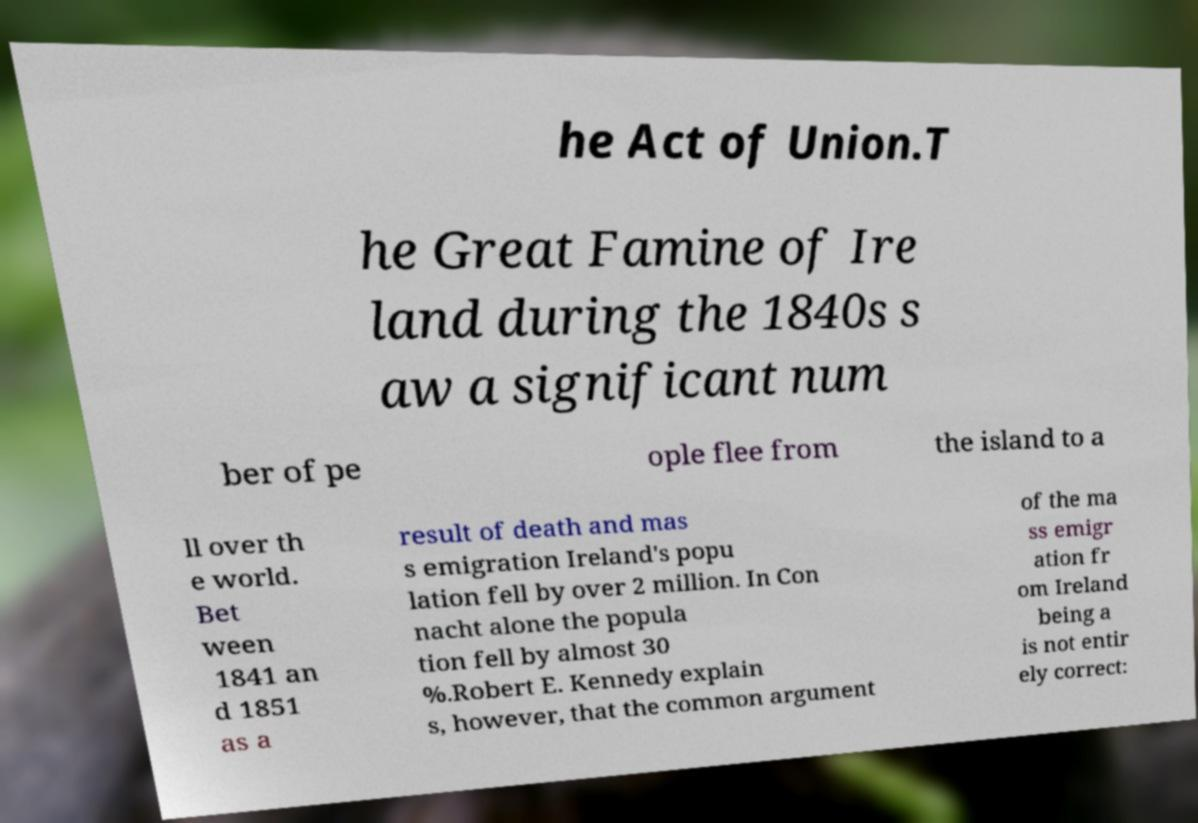Please read and relay the text visible in this image. What does it say? he Act of Union.T he Great Famine of Ire land during the 1840s s aw a significant num ber of pe ople flee from the island to a ll over th e world. Bet ween 1841 an d 1851 as a result of death and mas s emigration Ireland's popu lation fell by over 2 million. In Con nacht alone the popula tion fell by almost 30 %.Robert E. Kennedy explain s, however, that the common argument of the ma ss emigr ation fr om Ireland being a is not entir ely correct: 